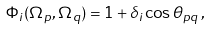Convert formula to latex. <formula><loc_0><loc_0><loc_500><loc_500>\Phi _ { i } ( \Omega _ { p } , \Omega _ { q } ) = 1 + \delta _ { i } \cos \theta _ { p q } \, ,</formula> 